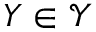Convert formula to latex. <formula><loc_0><loc_0><loc_500><loc_500>Y \in \mathcal { Y }</formula> 